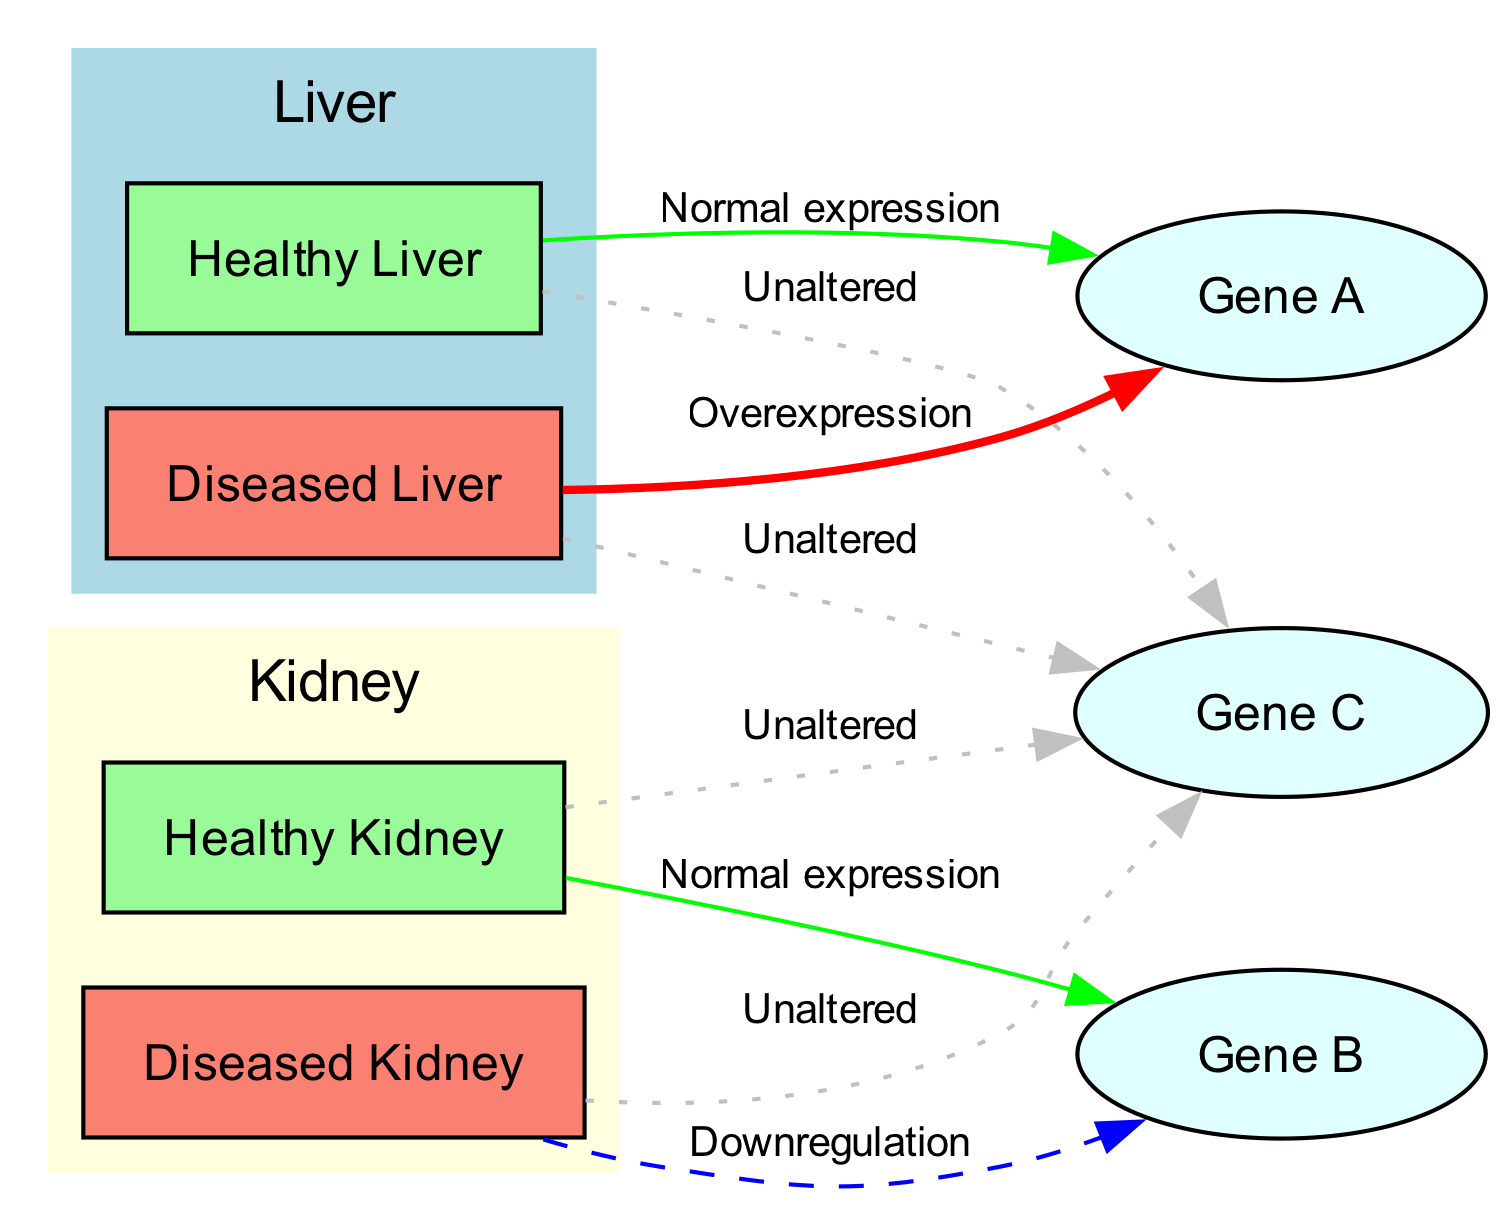What is the expression pattern of Gene A in diseased liver? The diagram indicates that Gene A is overexpressed in diseased liver tissues, as shown by the edge labeled "Overexpression" connecting the diseased liver node to Gene A.
Answer: Overexpression How many nodes are there in the diagram? The diagram consists of 7 nodes: 2 healthy tissue nodes, 2 diseased tissue nodes, and 3 gene nodes, which sums up to 7.
Answer: 7 What type of expression pattern is observed for Gene B in diseased kidney? The edge labeled "Downregulation" from the diseased kidney node to Gene B indicates that Gene B is downregulated in diseased kidney tissues.
Answer: Downregulation What is the relationship between healthy kidney and Gene C? The diagram shows that there is an edge labeled "Unaltered" from the healthy kidney node to Gene C, indicating that Gene C expression remains unaltered in healthy kidney tissues.
Answer: Unaltered Which gene remains unaltered in both healthy and diseased conditions? The edges labeled "Unaltered" connecting healthy liver, diseased liver, healthy kidney, and diseased kidney to Gene C show that Gene C remains unaltered in both healthy and diseased conditions.
Answer: Gene C How many edges are connected to the diseased liver node? The diseased liver node has two edges connected to it: one to Gene A (overexpression) and another to Gene C (unaltered), totaling two edges.
Answer: 2 Which gene is normal in expression in healthy liver tissues? The diagram states that Gene A is expressed at normal levels in healthy liver as indicated by the edge labeled "Normal expression" connecting healthy liver to Gene A.
Answer: Gene A What color is the node representing the healthy liver? The node for healthy liver is colored pale green according to the diagram’s specifications for healthy tissues.
Answer: Pale green What expression pattern is shown for Gene C in diseased liver? The diagram indicates that Gene C is unaltered even in the diseased liver, as shown by the edge labeled "Unaltered."
Answer: Unaltered 